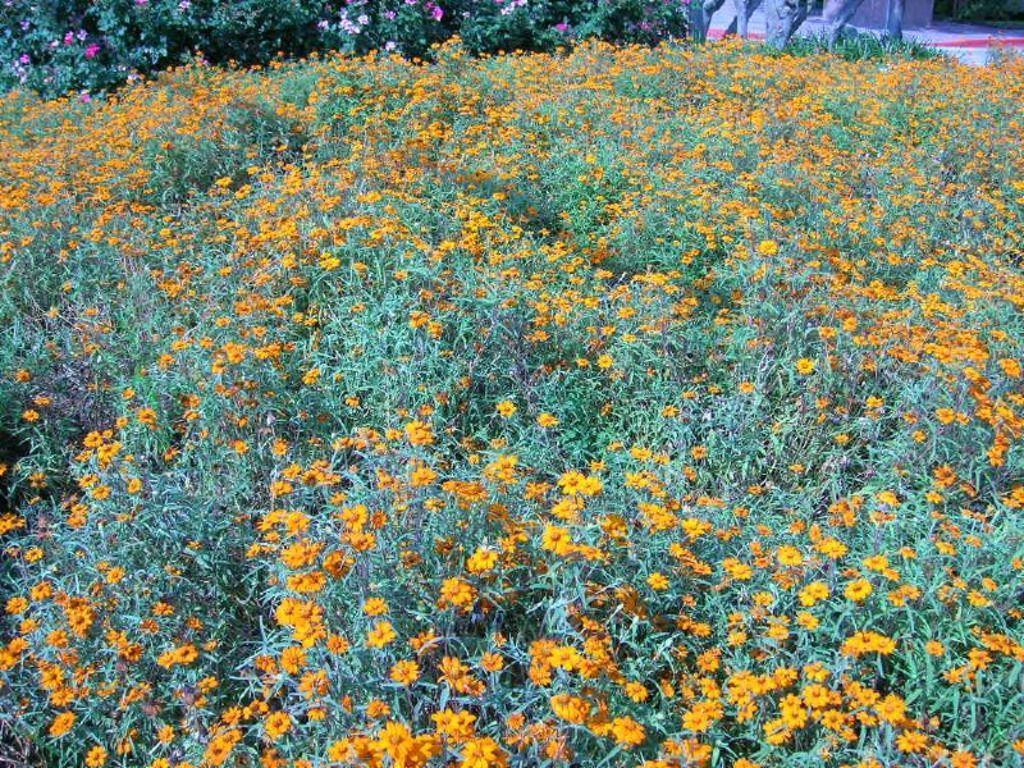What types of living organisms can be seen at the bottom of the image? There are plants and flowers at the bottom of the image. What types of living organisms can be seen in the background of the image? There are plants and flowers in the background of the image. How many children are playing with the spiders in the image? There are no children or spiders present in the image; it features plants and flowers. What type of mice can be seen interacting with the plants and flowers in the image? There are no mice present in the image; it features plants and flowers. 